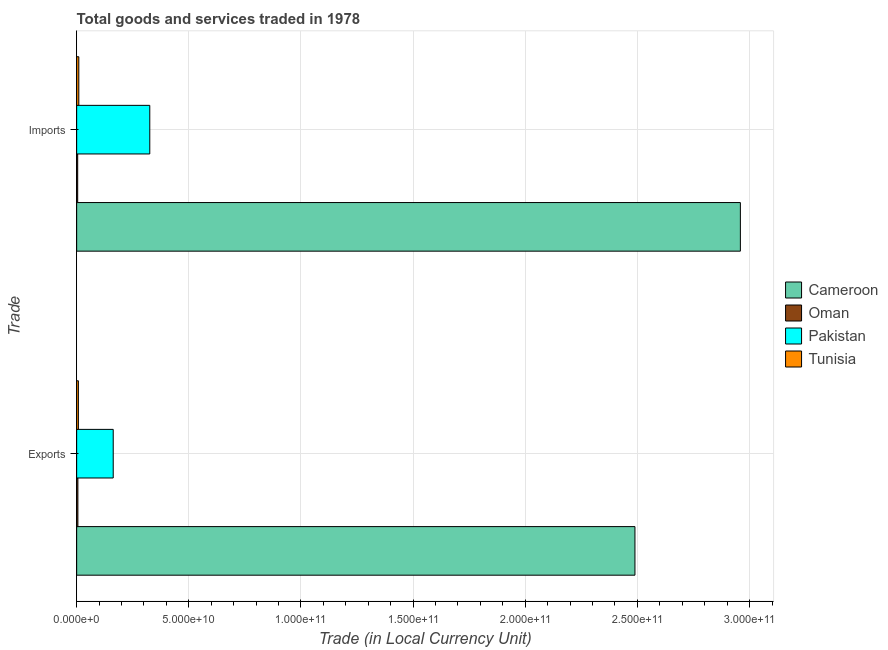How many different coloured bars are there?
Offer a very short reply. 4. How many bars are there on the 1st tick from the top?
Your answer should be very brief. 4. What is the label of the 1st group of bars from the top?
Keep it short and to the point. Imports. What is the imports of goods and services in Cameroon?
Provide a succinct answer. 2.96e+11. Across all countries, what is the maximum export of goods and services?
Give a very brief answer. 2.49e+11. Across all countries, what is the minimum export of goods and services?
Your answer should be compact. 5.52e+08. In which country was the imports of goods and services maximum?
Ensure brevity in your answer.  Cameroon. In which country was the imports of goods and services minimum?
Offer a very short reply. Oman. What is the total export of goods and services in the graph?
Your answer should be compact. 2.67e+11. What is the difference between the imports of goods and services in Cameroon and that in Oman?
Provide a succinct answer. 2.95e+11. What is the difference between the imports of goods and services in Cameroon and the export of goods and services in Oman?
Give a very brief answer. 2.95e+11. What is the average export of goods and services per country?
Make the answer very short. 6.66e+1. What is the difference between the imports of goods and services and export of goods and services in Tunisia?
Keep it short and to the point. 1.93e+08. What is the ratio of the imports of goods and services in Cameroon to that in Tunisia?
Your response must be concise. 307.52. Is the imports of goods and services in Pakistan less than that in Oman?
Make the answer very short. No. What does the 1st bar from the top in Imports represents?
Give a very brief answer. Tunisia. What does the 2nd bar from the bottom in Imports represents?
Make the answer very short. Oman. How many bars are there?
Offer a terse response. 8. Are the values on the major ticks of X-axis written in scientific E-notation?
Your response must be concise. Yes. Where does the legend appear in the graph?
Provide a succinct answer. Center right. How many legend labels are there?
Your response must be concise. 4. What is the title of the graph?
Your answer should be compact. Total goods and services traded in 1978. Does "Senegal" appear as one of the legend labels in the graph?
Make the answer very short. No. What is the label or title of the X-axis?
Provide a succinct answer. Trade (in Local Currency Unit). What is the label or title of the Y-axis?
Provide a short and direct response. Trade. What is the Trade (in Local Currency Unit) in Cameroon in Exports?
Your answer should be very brief. 2.49e+11. What is the Trade (in Local Currency Unit) of Oman in Exports?
Offer a terse response. 5.52e+08. What is the Trade (in Local Currency Unit) in Pakistan in Exports?
Your answer should be compact. 1.63e+1. What is the Trade (in Local Currency Unit) in Tunisia in Exports?
Your answer should be compact. 7.69e+08. What is the Trade (in Local Currency Unit) in Cameroon in Imports?
Keep it short and to the point. 2.96e+11. What is the Trade (in Local Currency Unit) in Oman in Imports?
Keep it short and to the point. 4.61e+08. What is the Trade (in Local Currency Unit) of Pakistan in Imports?
Keep it short and to the point. 3.26e+1. What is the Trade (in Local Currency Unit) of Tunisia in Imports?
Provide a succinct answer. 9.62e+08. Across all Trade, what is the maximum Trade (in Local Currency Unit) in Cameroon?
Your response must be concise. 2.96e+11. Across all Trade, what is the maximum Trade (in Local Currency Unit) in Oman?
Make the answer very short. 5.52e+08. Across all Trade, what is the maximum Trade (in Local Currency Unit) in Pakistan?
Your answer should be very brief. 3.26e+1. Across all Trade, what is the maximum Trade (in Local Currency Unit) in Tunisia?
Your response must be concise. 9.62e+08. Across all Trade, what is the minimum Trade (in Local Currency Unit) of Cameroon?
Provide a short and direct response. 2.49e+11. Across all Trade, what is the minimum Trade (in Local Currency Unit) in Oman?
Keep it short and to the point. 4.61e+08. Across all Trade, what is the minimum Trade (in Local Currency Unit) in Pakistan?
Your response must be concise. 1.63e+1. Across all Trade, what is the minimum Trade (in Local Currency Unit) of Tunisia?
Keep it short and to the point. 7.69e+08. What is the total Trade (in Local Currency Unit) in Cameroon in the graph?
Provide a short and direct response. 5.45e+11. What is the total Trade (in Local Currency Unit) of Oman in the graph?
Make the answer very short. 1.01e+09. What is the total Trade (in Local Currency Unit) of Pakistan in the graph?
Keep it short and to the point. 4.89e+1. What is the total Trade (in Local Currency Unit) in Tunisia in the graph?
Make the answer very short. 1.73e+09. What is the difference between the Trade (in Local Currency Unit) of Cameroon in Exports and that in Imports?
Make the answer very short. -4.70e+1. What is the difference between the Trade (in Local Currency Unit) of Oman in Exports and that in Imports?
Your answer should be very brief. 9.08e+07. What is the difference between the Trade (in Local Currency Unit) in Pakistan in Exports and that in Imports?
Give a very brief answer. -1.63e+1. What is the difference between the Trade (in Local Currency Unit) of Tunisia in Exports and that in Imports?
Offer a terse response. -1.93e+08. What is the difference between the Trade (in Local Currency Unit) in Cameroon in Exports and the Trade (in Local Currency Unit) in Oman in Imports?
Keep it short and to the point. 2.48e+11. What is the difference between the Trade (in Local Currency Unit) in Cameroon in Exports and the Trade (in Local Currency Unit) in Pakistan in Imports?
Keep it short and to the point. 2.16e+11. What is the difference between the Trade (in Local Currency Unit) in Cameroon in Exports and the Trade (in Local Currency Unit) in Tunisia in Imports?
Your response must be concise. 2.48e+11. What is the difference between the Trade (in Local Currency Unit) in Oman in Exports and the Trade (in Local Currency Unit) in Pakistan in Imports?
Your answer should be compact. -3.20e+1. What is the difference between the Trade (in Local Currency Unit) of Oman in Exports and the Trade (in Local Currency Unit) of Tunisia in Imports?
Your answer should be compact. -4.10e+08. What is the difference between the Trade (in Local Currency Unit) in Pakistan in Exports and the Trade (in Local Currency Unit) in Tunisia in Imports?
Keep it short and to the point. 1.53e+1. What is the average Trade (in Local Currency Unit) in Cameroon per Trade?
Offer a very short reply. 2.72e+11. What is the average Trade (in Local Currency Unit) in Oman per Trade?
Ensure brevity in your answer.  5.07e+08. What is the average Trade (in Local Currency Unit) of Pakistan per Trade?
Provide a short and direct response. 2.45e+1. What is the average Trade (in Local Currency Unit) of Tunisia per Trade?
Make the answer very short. 8.66e+08. What is the difference between the Trade (in Local Currency Unit) of Cameroon and Trade (in Local Currency Unit) of Oman in Exports?
Keep it short and to the point. 2.48e+11. What is the difference between the Trade (in Local Currency Unit) of Cameroon and Trade (in Local Currency Unit) of Pakistan in Exports?
Your answer should be compact. 2.33e+11. What is the difference between the Trade (in Local Currency Unit) in Cameroon and Trade (in Local Currency Unit) in Tunisia in Exports?
Keep it short and to the point. 2.48e+11. What is the difference between the Trade (in Local Currency Unit) in Oman and Trade (in Local Currency Unit) in Pakistan in Exports?
Your answer should be compact. -1.58e+1. What is the difference between the Trade (in Local Currency Unit) of Oman and Trade (in Local Currency Unit) of Tunisia in Exports?
Keep it short and to the point. -2.17e+08. What is the difference between the Trade (in Local Currency Unit) of Pakistan and Trade (in Local Currency Unit) of Tunisia in Exports?
Offer a terse response. 1.55e+1. What is the difference between the Trade (in Local Currency Unit) of Cameroon and Trade (in Local Currency Unit) of Oman in Imports?
Offer a terse response. 2.95e+11. What is the difference between the Trade (in Local Currency Unit) in Cameroon and Trade (in Local Currency Unit) in Pakistan in Imports?
Your answer should be compact. 2.63e+11. What is the difference between the Trade (in Local Currency Unit) in Cameroon and Trade (in Local Currency Unit) in Tunisia in Imports?
Keep it short and to the point. 2.95e+11. What is the difference between the Trade (in Local Currency Unit) in Oman and Trade (in Local Currency Unit) in Pakistan in Imports?
Make the answer very short. -3.21e+1. What is the difference between the Trade (in Local Currency Unit) of Oman and Trade (in Local Currency Unit) of Tunisia in Imports?
Your response must be concise. -5.01e+08. What is the difference between the Trade (in Local Currency Unit) in Pakistan and Trade (in Local Currency Unit) in Tunisia in Imports?
Your response must be concise. 3.16e+1. What is the ratio of the Trade (in Local Currency Unit) of Cameroon in Exports to that in Imports?
Ensure brevity in your answer.  0.84. What is the ratio of the Trade (in Local Currency Unit) of Oman in Exports to that in Imports?
Your answer should be very brief. 1.2. What is the ratio of the Trade (in Local Currency Unit) of Pakistan in Exports to that in Imports?
Provide a succinct answer. 0.5. What is the ratio of the Trade (in Local Currency Unit) in Tunisia in Exports to that in Imports?
Offer a very short reply. 0.8. What is the difference between the highest and the second highest Trade (in Local Currency Unit) of Cameroon?
Provide a short and direct response. 4.70e+1. What is the difference between the highest and the second highest Trade (in Local Currency Unit) of Oman?
Your answer should be very brief. 9.08e+07. What is the difference between the highest and the second highest Trade (in Local Currency Unit) in Pakistan?
Provide a succinct answer. 1.63e+1. What is the difference between the highest and the second highest Trade (in Local Currency Unit) of Tunisia?
Your answer should be very brief. 1.93e+08. What is the difference between the highest and the lowest Trade (in Local Currency Unit) of Cameroon?
Your answer should be compact. 4.70e+1. What is the difference between the highest and the lowest Trade (in Local Currency Unit) in Oman?
Give a very brief answer. 9.08e+07. What is the difference between the highest and the lowest Trade (in Local Currency Unit) in Pakistan?
Your answer should be compact. 1.63e+1. What is the difference between the highest and the lowest Trade (in Local Currency Unit) in Tunisia?
Your response must be concise. 1.93e+08. 